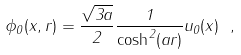Convert formula to latex. <formula><loc_0><loc_0><loc_500><loc_500>\phi _ { 0 } ( x , r ) = \frac { \sqrt { 3 a } } { 2 } \frac { 1 } { \cosh ^ { 2 } ( a r ) } u _ { 0 } ( x ) \ ,</formula> 